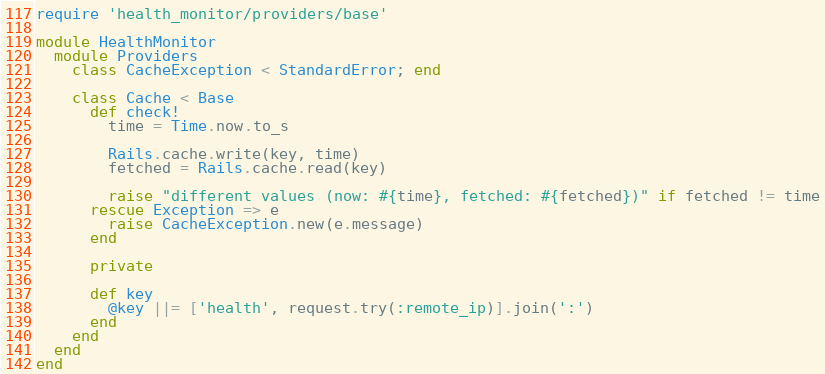<code> <loc_0><loc_0><loc_500><loc_500><_Ruby_>require 'health_monitor/providers/base'

module HealthMonitor
  module Providers
    class CacheException < StandardError; end

    class Cache < Base
      def check!
        time = Time.now.to_s

        Rails.cache.write(key, time)
        fetched = Rails.cache.read(key)

        raise "different values (now: #{time}, fetched: #{fetched})" if fetched != time
      rescue Exception => e
        raise CacheException.new(e.message)
      end

      private

      def key
        @key ||= ['health', request.try(:remote_ip)].join(':')
      end
    end
  end
end
</code> 